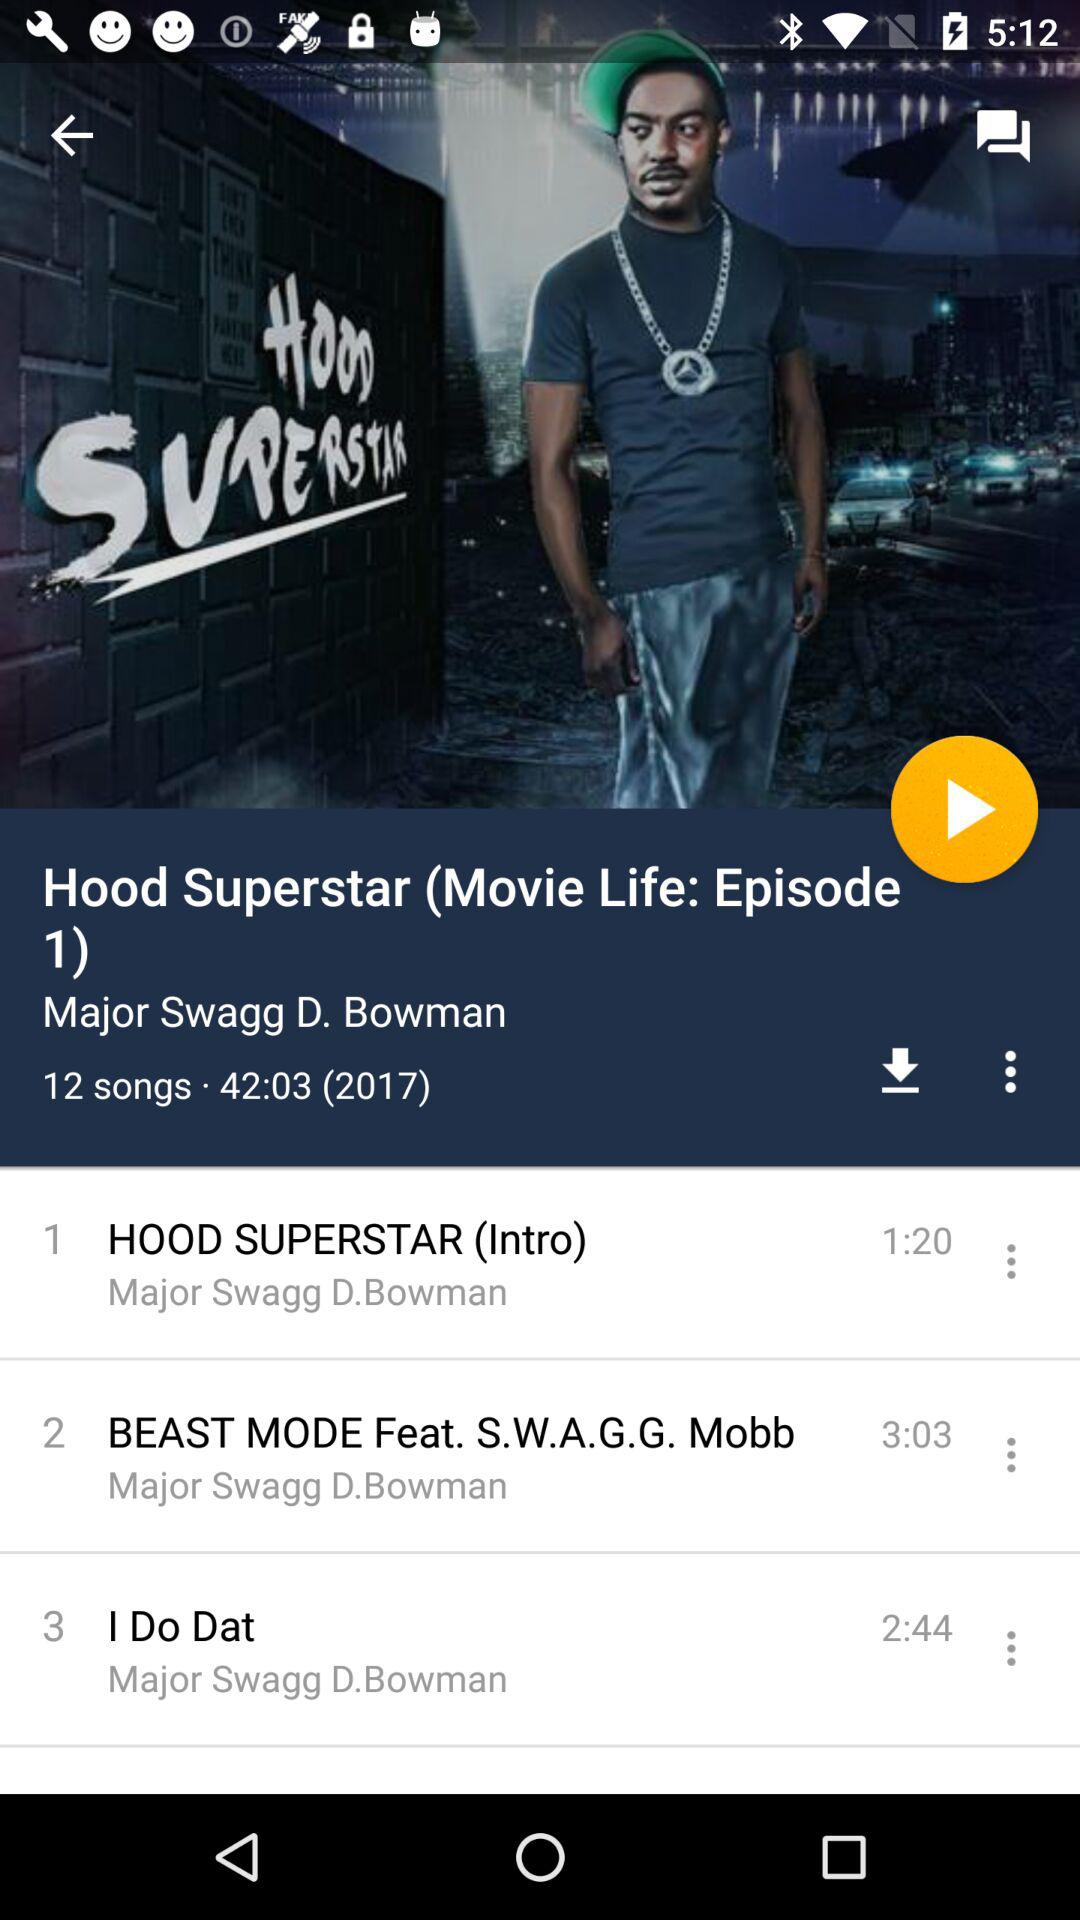Who is the singer of "HOOD SUPERSTAR (Intro)"? The singer of "HOOD SUPERSTAR (Intro)" is Major Swagg D. Bowman. 